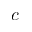Convert formula to latex. <formula><loc_0><loc_0><loc_500><loc_500>c</formula> 